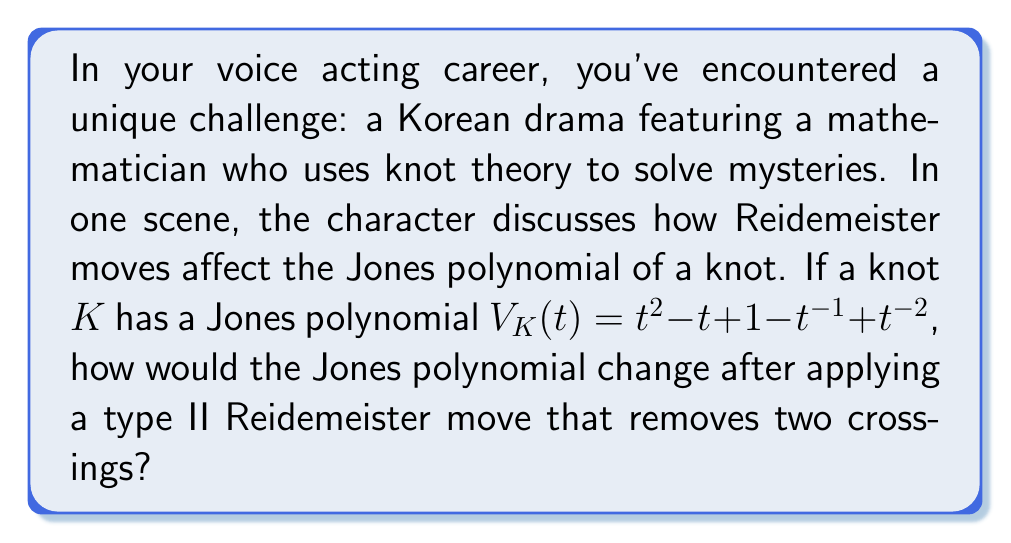Solve this math problem. Let's approach this step-by-step:

1) First, recall that the Jones polynomial is a knot invariant, meaning it remains unchanged under Reidemeister moves of types I and III.

2) However, the type II Reidemeister move can affect the Jones polynomial in a specific way. When two crossings are removed by a type II move, the Jones polynomial is multiplied by $(-A^3)^{\pm 1}$, where $A = t^{-1/4}$.

3) In this case, we're removing two crossings, so we need to multiply the original Jones polynomial by $(-A^3)^{-1} = -A^{-3}$.

4) Let's express this in terms of $t$:
   $-A^{-3} = -(t^{-1/4})^{-3} = -t^{3/4}$

5) Now, we multiply the original polynomial by $-t^{3/4}$:

   $-t^{3/4}(t^2 - t + 1 - t^{-1} + t^{-2})$

6) Simplifying:
   $-t^{11/4} + t^{7/4} - t^{3/4} + t^{-1/4} - t^{-5/4}$

7) To express this in the standard form of a Jones polynomial (with integer powers of $t$), we multiply everything by $t^{5/4}$:

   $-t^4 + t^3 - t^2 + t - 1$

This is the new Jones polynomial after the type II Reidemeister move.
Answer: $-t^4 + t^3 - t^2 + t - 1$ 